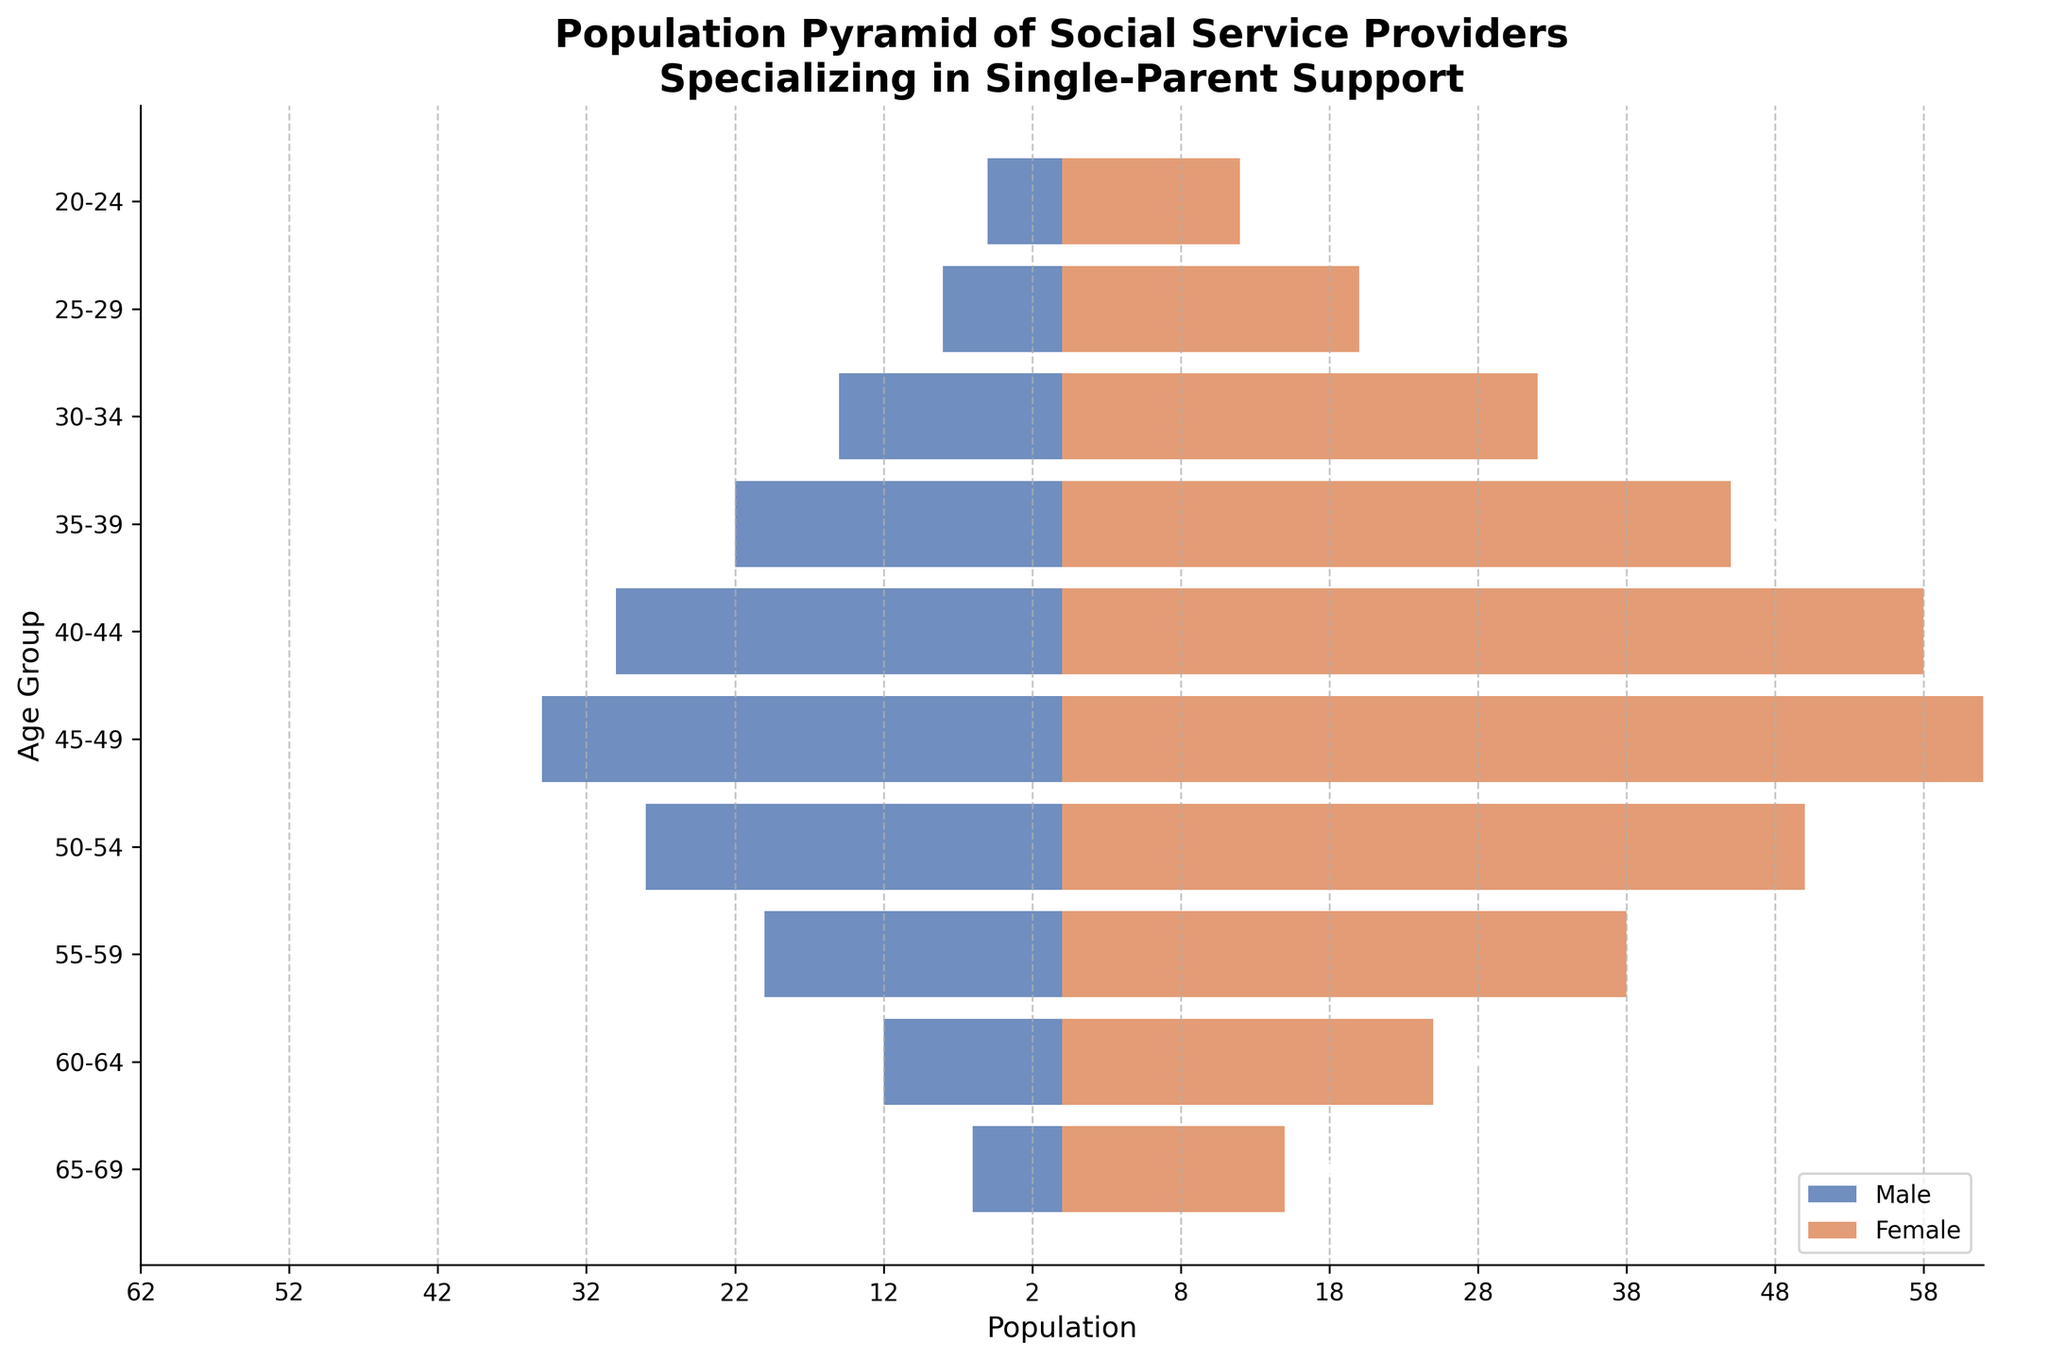what is the title of the figure? The title of the figure is usually displayed at the top and provides an overall description of what the figure represents. In this case, it is clearly stated.
Answer: Population Pyramid of Social Service Providers Specializing in Single-Parent Support What is the color used to represent males in the figure? The figure has two horizontal bar plots with different colors. The males are represented by the bars in blue color.
Answer: Blue Which age group has the highest number of female social service providers? By examining the lengths of the bars corresponding to females, the age group with the longest bar would have the highest number. This is the 45-49 age group.
Answer: 45-49 How many males are there in the 30-34 age group? By looking at the negative bar for the 30-34 age group on the left-hand side, the number next to the bar will give the value. It shows -15, which means there are 15 males.
Answer: 15 What is the combined number of social service providers (both males and females) in the 55-59 age group? To find the total number, sum the absolute values of the male and female numbers for that age group. There are 20 males and 38 females, so 20 + 38 = 58.
Answer: 58 Which gender has more representation in the 40-44 age group? By comparing the lengths of the bars for males and females in this age group, the female bar is longer.
Answer: Female What is the difference in the number of males and females for the 25-29 age group? Subtract the number of males from the number of females for this age group: 20 (females) - 8 (males) = 12.
Answer: 12 In which age group do females significantly outnumber males? The age group where the length of the female bar is much greater than the male bar indicates significant outnumbering. This is quite noticeable in the 35-39 age group.
Answer: 35-39 What is the total number of social service providers aged between 25-34? First, sum the values for both males and females in the 25-29 and 30-34 age groups and then combine them. For 25-29: 8 (males) + 20 (females). For 30-34: 15 (males) + 32 (females). So, (8+20) + (15+32) = 75.
Answer: 75 How does the number of female social service providers aged 50-54 compare to those aged 55-59? Compare the female values for both age groups, 50-54 has 50 females and 55-59 has 38 females, so there are more females in the 50-54 age group.
Answer: More in 50-54 